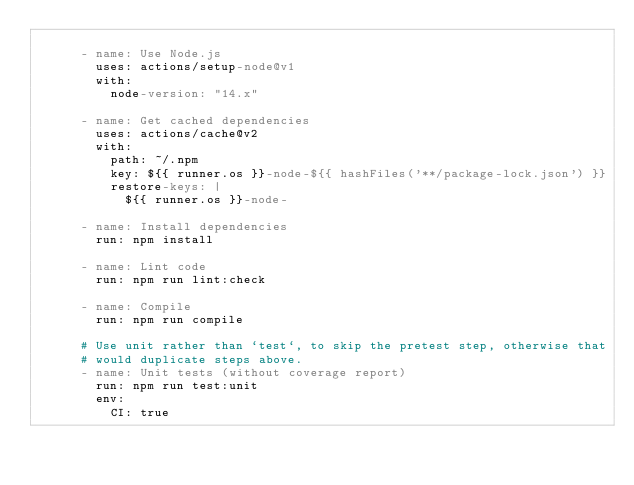<code> <loc_0><loc_0><loc_500><loc_500><_YAML_>
      - name: Use Node.js
        uses: actions/setup-node@v1
        with:
          node-version: "14.x"

      - name: Get cached dependencies
        uses: actions/cache@v2
        with:
          path: ~/.npm
          key: ${{ runner.os }}-node-${{ hashFiles('**/package-lock.json') }}
          restore-keys: |
            ${{ runner.os }}-node-

      - name: Install dependencies
        run: npm install

      - name: Lint code
        run: npm run lint:check

      - name: Compile
        run: npm run compile

      # Use unit rather than `test`, to skip the pretest step, otherwise that
      # would duplicate steps above.
      - name: Unit tests (without coverage report)
        run: npm run test:unit
        env:
          CI: true
</code> 